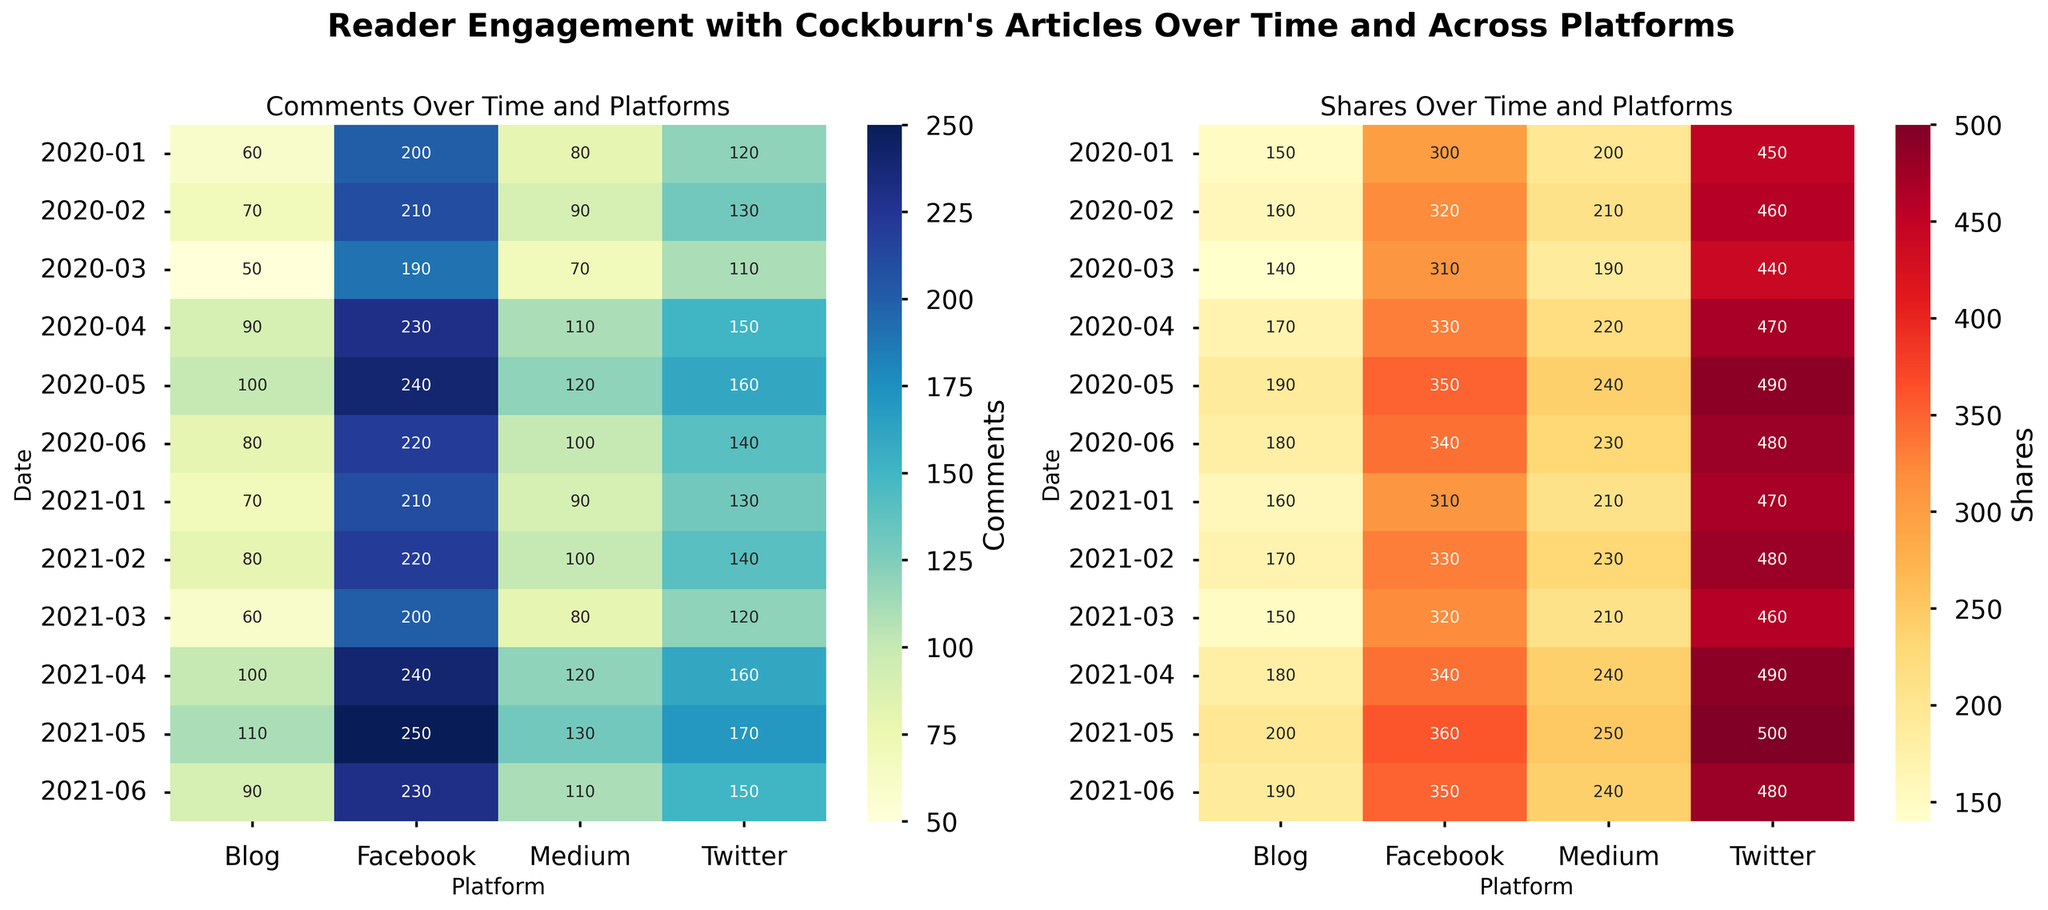What is the trend in comments on Twitter from January 2020 to June 2021? By looking at the heatmap for comments over time on Twitter, we can observe the annotations representing the number of comments in each month. Starting from January 2020 to June 2021, the numbers fluctuate slightly with an overall increasing trend. Beginning at 120 in January 2020, increasing through subsequent months with some fluctuations, up to 150 in June 2021.
Answer: Increasing trend Which social media platform had the highest number of shares in May 2021? Referring to the heatmap for shares in May 2021, we can compare the annotated values across all platforms. Facebook had 360 shares, which is the highest compared to Twitter (500), Medium (250), and Blog (200).
Answer: Twitter How do the comments in June 2020 on Medium compare to those in June 2021? By looking at the heatmap for comments, we can directly compare the values for Medium in June 2020 and June 2021. June 2020 had 100 comments, while June 2021 had 110 comments. Comments increased from June 2020 to June 2021.
Answer: Increased What platform had the least number of comments overall in January 2021? Analyzing the heatmap for comments in January 2021, the platform with the lowest annotated value is Blog with 70 comments compared to others: Twitter (130), Facebook (210), and Medium (90).
Answer: Blog Which platform had the highest increase in comments from January 2020 to June 2021? We need to identify the comments in January 2020 and June 2021 for each platform. For Twitter, comments increased from 120 to 150 (+30); for Facebook, from 200 to 230 (+30); for Medium, from 80 to 110 (+30); for Blog, from 60 to 90 (+30). All platforms show equal increases.
Answer: Multiple - All platforms increased equally What range of values are observed for shares on Facebook between January 2020 and June 2021? Observing the heatmap for shares over time on Facebook, the values range from a minimum of 300 in January 2020 to a maximum of 360 in May 2021.
Answer: 300 to 360 Are there any platforms where the number of shares remained the same over two consecutive months? If so, which platforms and months are they? By scanning the heatmap for shares, there are no two consecutive months where the shares remained exactly the same across any platform from January 2020 to June 2021.
Answer: None Which platform shows the most consistent trend in the number of comments over the observed period? By evaluating the uniformity in color intensities for comments across platforms, Facebook exhibits a consistent pattern with less fluctuation as the values hover close to each other between 200 and 250 consistently. Other platforms show more variability.
Answer: Facebook What is the average number of comments on Blog from January 2020 to June 2021? Sum the comments for Blog across all months and divide by the number of months. (60+70+50+90+100+80+70+80+60+100+110+90)/12 = 960/12 = 80.
Answer: 80 